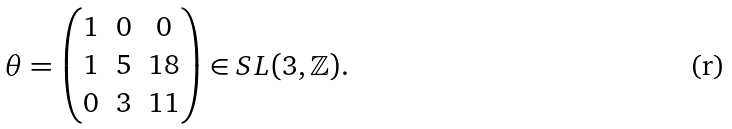<formula> <loc_0><loc_0><loc_500><loc_500>\theta = \left ( \begin{matrix} 1 & 0 & 0 \\ 1 & 5 & 1 8 \\ 0 & 3 & 1 1 \end{matrix} \right ) \in { S L ( 3 , \mathbb { Z } ) } .</formula> 